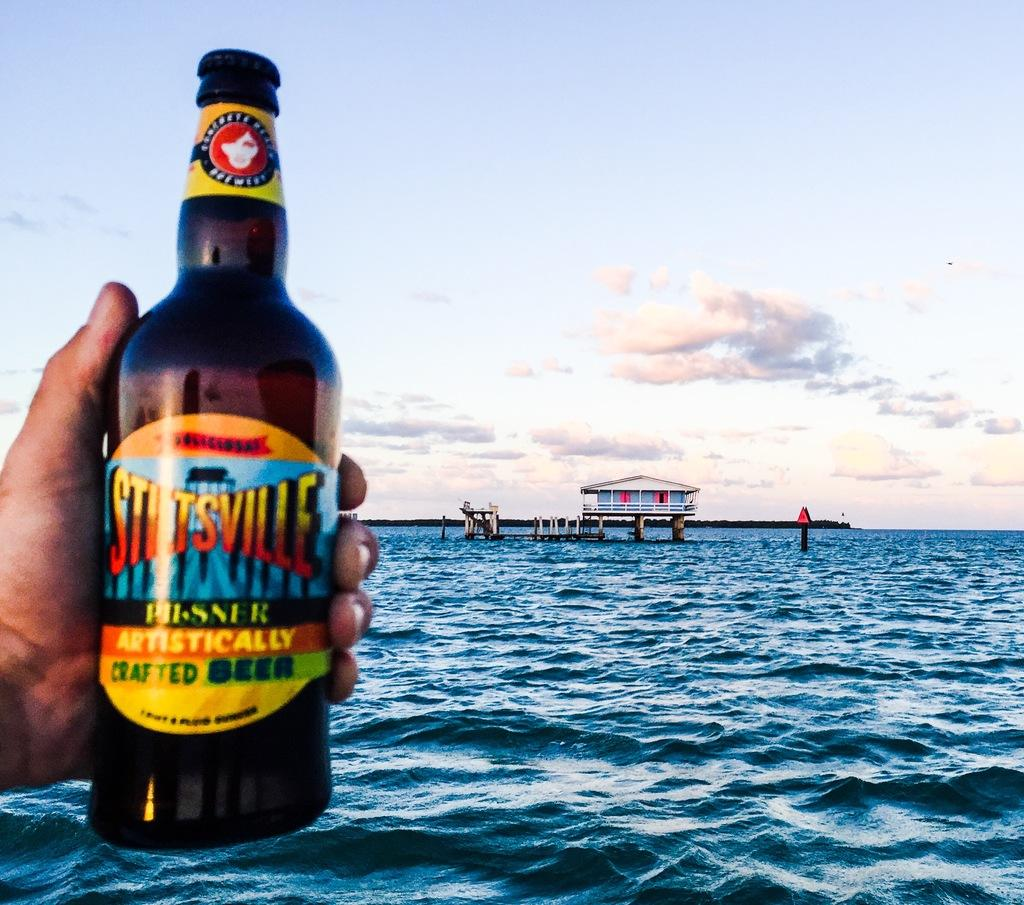Provide a one-sentence caption for the provided image. An ad showing a bottle of Stitsville crafted beer being held by someone with the sea in the background. 